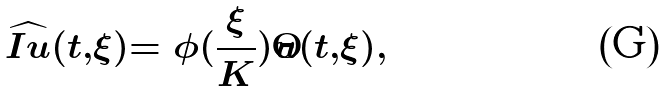Convert formula to latex. <formula><loc_0><loc_0><loc_500><loc_500>\widehat { I u } ( t , \xi ) = \phi ( \frac { \xi } { K } ) \hat { u } ( t , \xi ) ,</formula> 